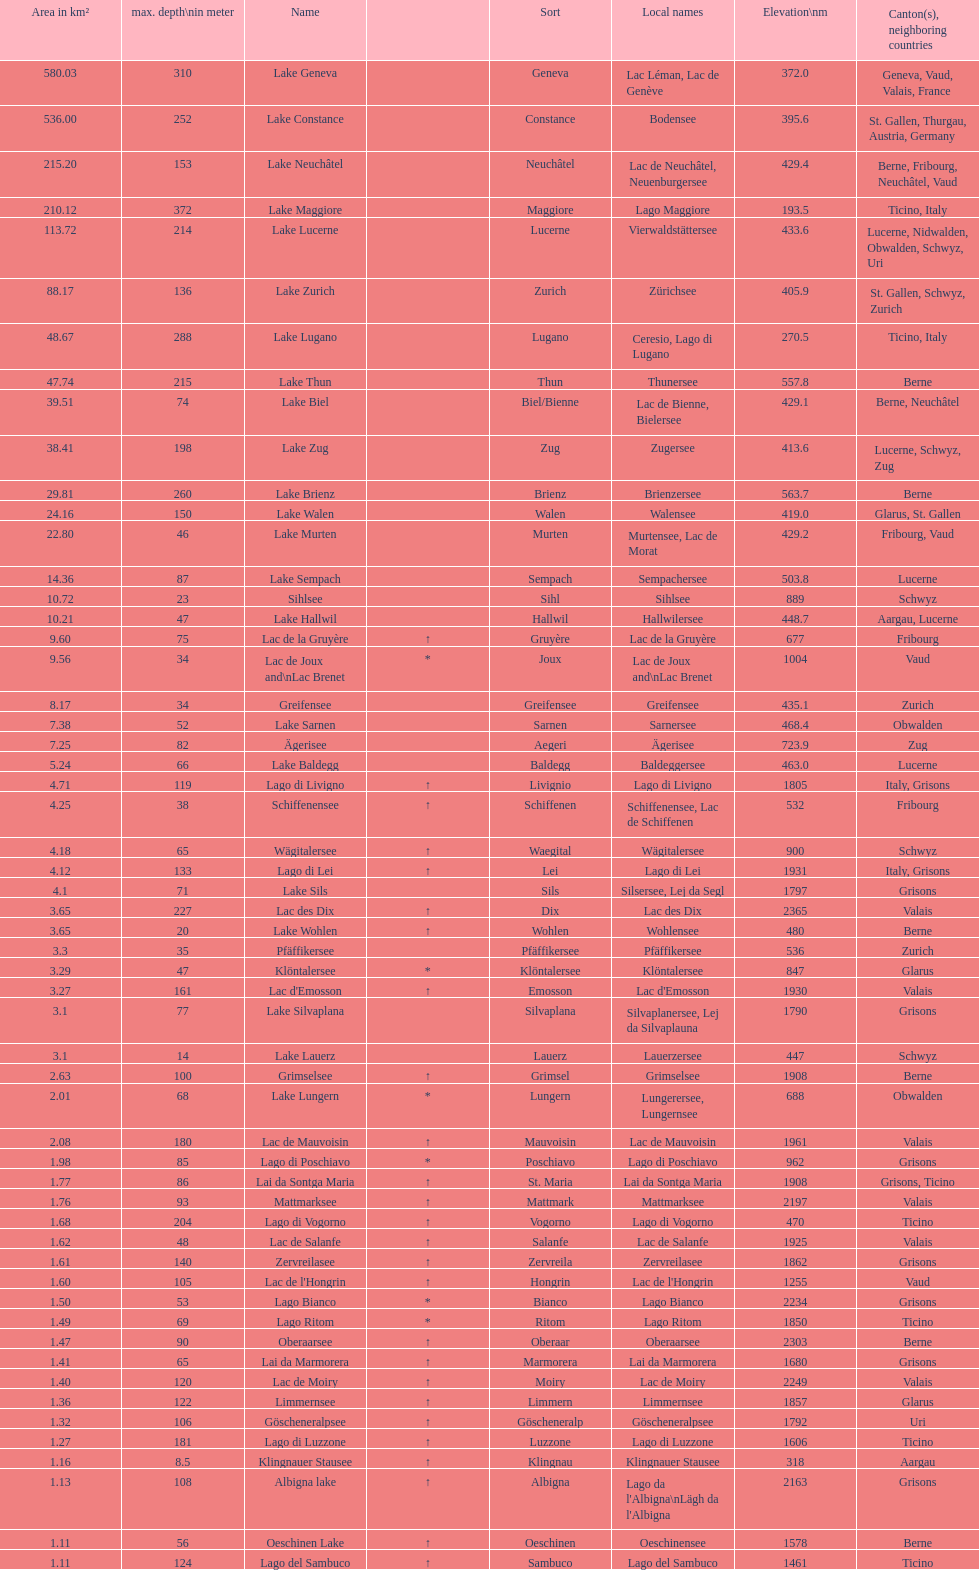Which lake has at least 580 area in km²? Lake Geneva. 